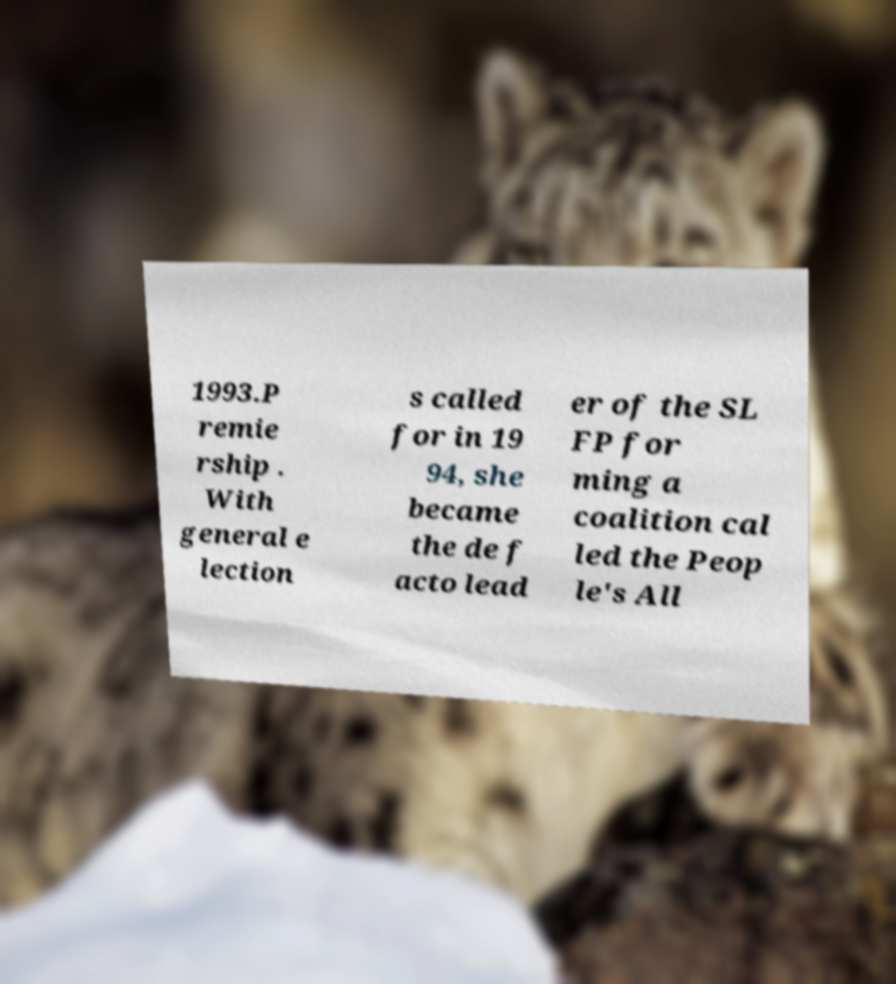Could you extract and type out the text from this image? 1993.P remie rship . With general e lection s called for in 19 94, she became the de f acto lead er of the SL FP for ming a coalition cal led the Peop le's All 